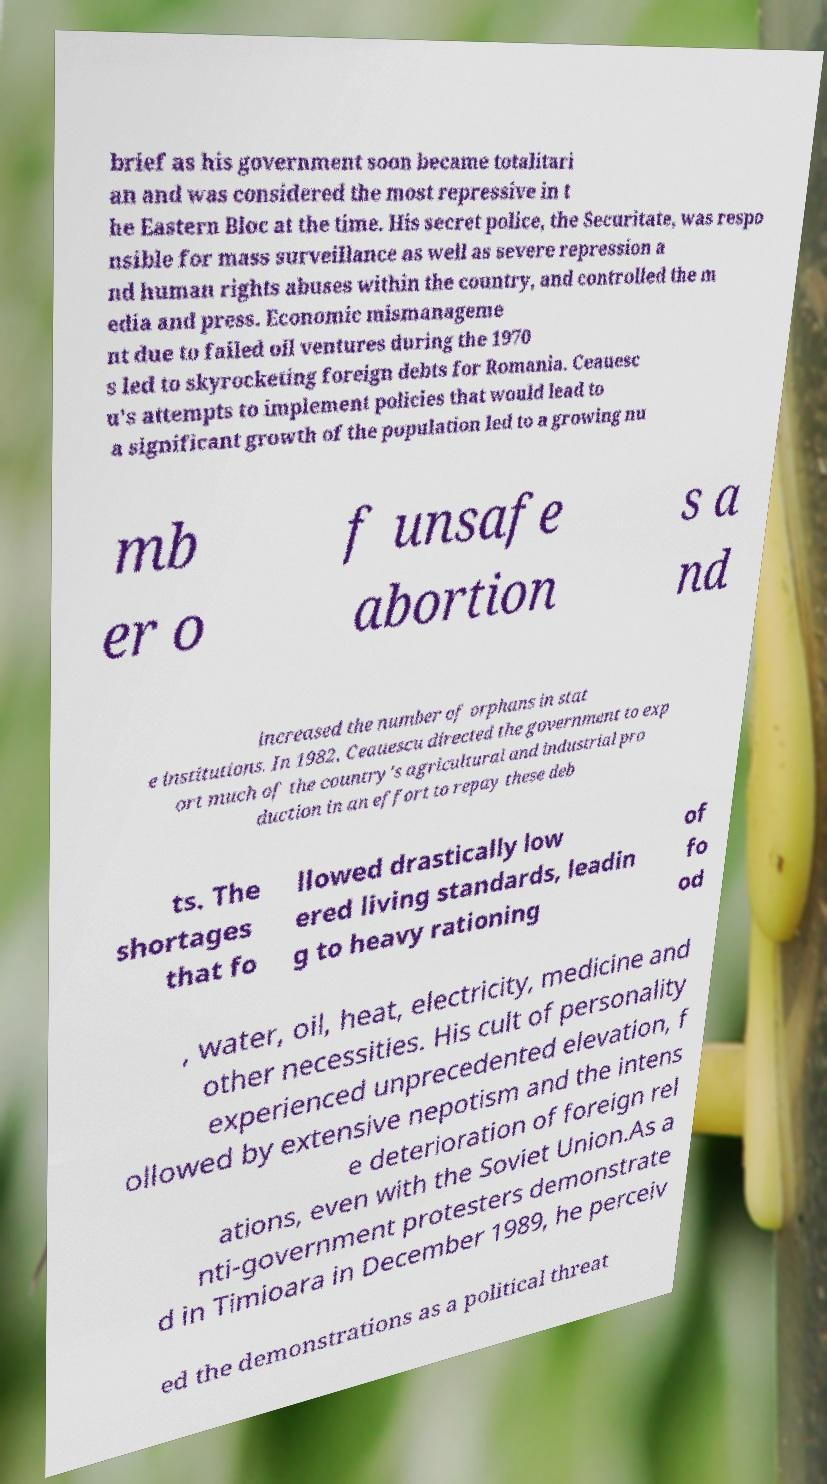Please read and relay the text visible in this image. What does it say? brief as his government soon became totalitari an and was considered the most repressive in t he Eastern Bloc at the time. His secret police, the Securitate, was respo nsible for mass surveillance as well as severe repression a nd human rights abuses within the country, and controlled the m edia and press. Economic mismanageme nt due to failed oil ventures during the 1970 s led to skyrocketing foreign debts for Romania. Ceauesc u's attempts to implement policies that would lead to a significant growth of the population led to a growing nu mb er o f unsafe abortion s a nd increased the number of orphans in stat e institutions. In 1982, Ceauescu directed the government to exp ort much of the country's agricultural and industrial pro duction in an effort to repay these deb ts. The shortages that fo llowed drastically low ered living standards, leadin g to heavy rationing of fo od , water, oil, heat, electricity, medicine and other necessities. His cult of personality experienced unprecedented elevation, f ollowed by extensive nepotism and the intens e deterioration of foreign rel ations, even with the Soviet Union.As a nti-government protesters demonstrate d in Timioara in December 1989, he perceiv ed the demonstrations as a political threat 